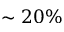Convert formula to latex. <formula><loc_0><loc_0><loc_500><loc_500>\sim 2 0 \%</formula> 